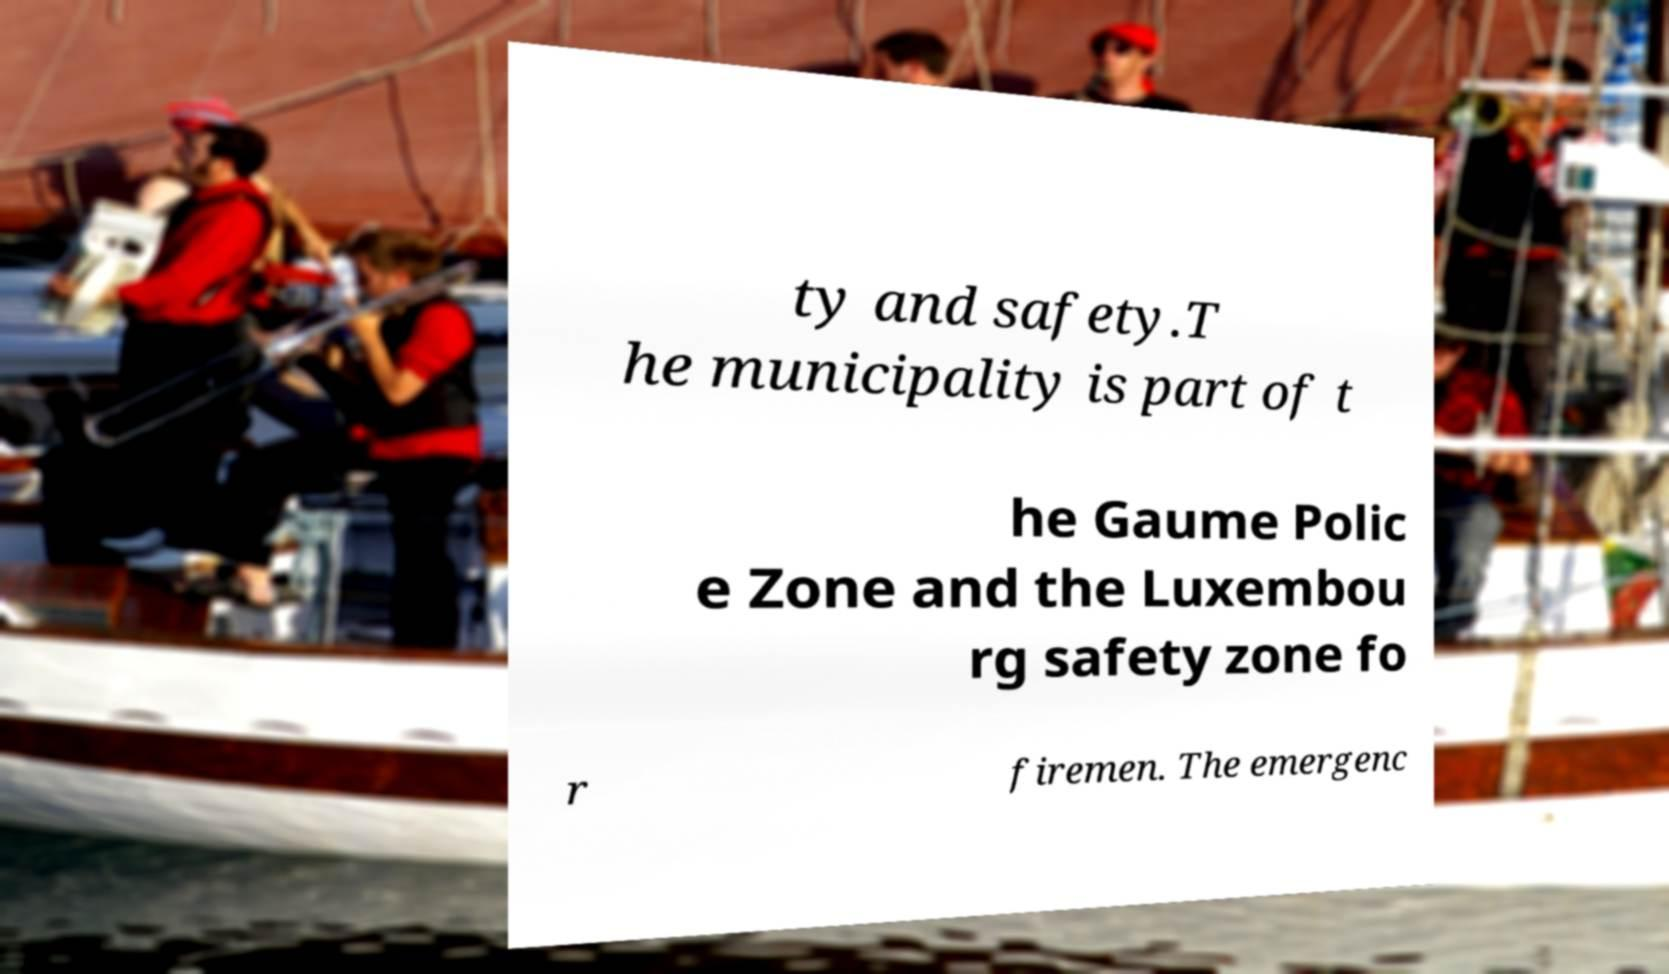Can you read and provide the text displayed in the image?This photo seems to have some interesting text. Can you extract and type it out for me? ty and safety.T he municipality is part of t he Gaume Polic e Zone and the Luxembou rg safety zone fo r firemen. The emergenc 